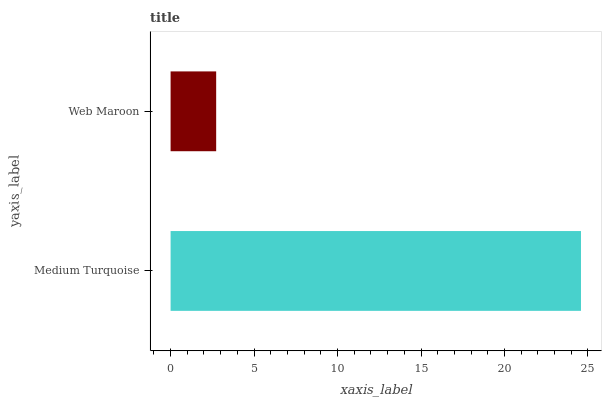Is Web Maroon the minimum?
Answer yes or no. Yes. Is Medium Turquoise the maximum?
Answer yes or no. Yes. Is Web Maroon the maximum?
Answer yes or no. No. Is Medium Turquoise greater than Web Maroon?
Answer yes or no. Yes. Is Web Maroon less than Medium Turquoise?
Answer yes or no. Yes. Is Web Maroon greater than Medium Turquoise?
Answer yes or no. No. Is Medium Turquoise less than Web Maroon?
Answer yes or no. No. Is Medium Turquoise the high median?
Answer yes or no. Yes. Is Web Maroon the low median?
Answer yes or no. Yes. Is Web Maroon the high median?
Answer yes or no. No. Is Medium Turquoise the low median?
Answer yes or no. No. 